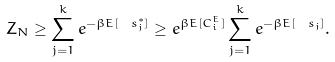Convert formula to latex. <formula><loc_0><loc_0><loc_500><loc_500>Z _ { N } \geq \sum _ { j = 1 } ^ { k } e ^ { - \beta E [ \, \ s _ { j } ^ { * } ] } \geq e ^ { \beta E [ C _ { i } ^ { E } ] } \sum _ { j = 1 } ^ { k } e ^ { - \beta E [ \, \ s _ { j } ] } .</formula> 